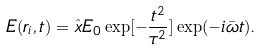Convert formula to latex. <formula><loc_0><loc_0><loc_500><loc_500>E ( { r } _ { i } , t ) = \hat { x } E _ { 0 } \exp [ - \frac { t ^ { 2 } } { \tau ^ { 2 } } ] \exp ( - i \bar { \omega } t ) .</formula> 